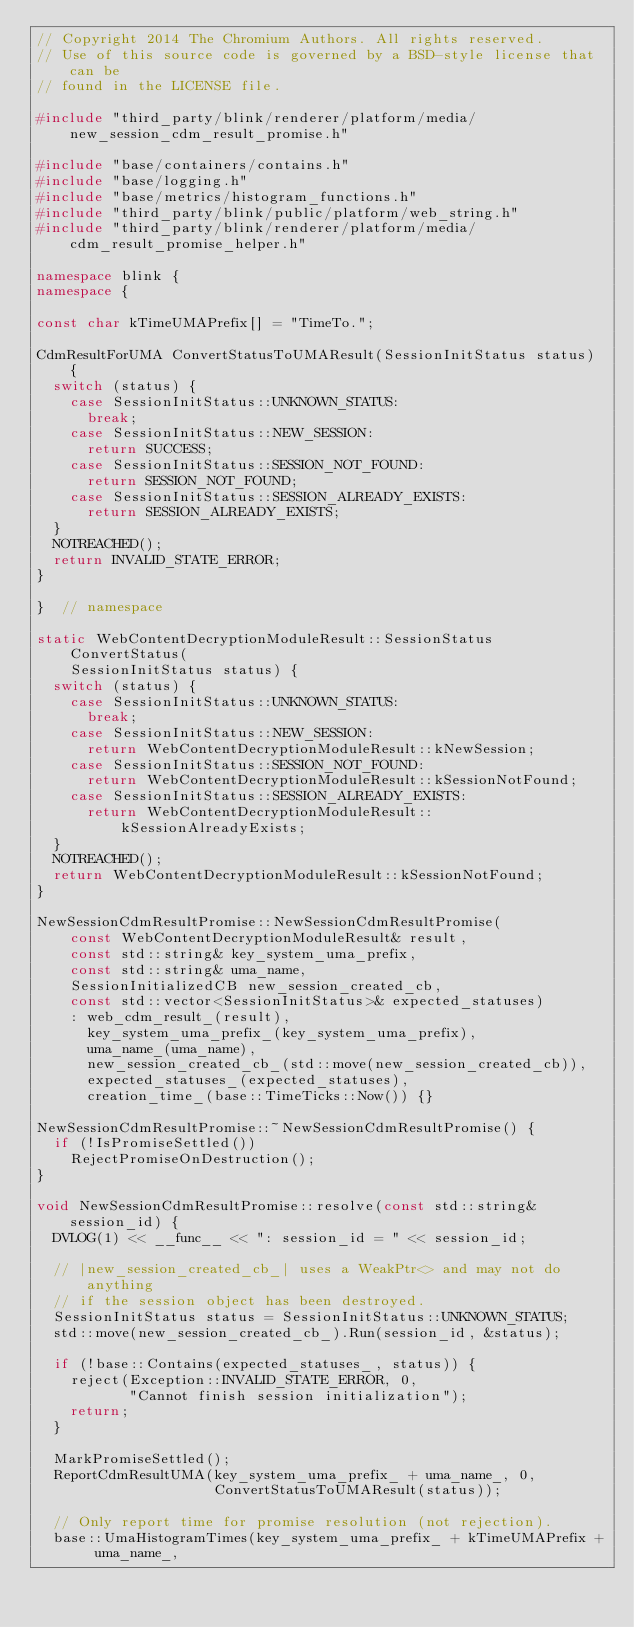Convert code to text. <code><loc_0><loc_0><loc_500><loc_500><_C++_>// Copyright 2014 The Chromium Authors. All rights reserved.
// Use of this source code is governed by a BSD-style license that can be
// found in the LICENSE file.

#include "third_party/blink/renderer/platform/media/new_session_cdm_result_promise.h"

#include "base/containers/contains.h"
#include "base/logging.h"
#include "base/metrics/histogram_functions.h"
#include "third_party/blink/public/platform/web_string.h"
#include "third_party/blink/renderer/platform/media/cdm_result_promise_helper.h"

namespace blink {
namespace {

const char kTimeUMAPrefix[] = "TimeTo.";

CdmResultForUMA ConvertStatusToUMAResult(SessionInitStatus status) {
  switch (status) {
    case SessionInitStatus::UNKNOWN_STATUS:
      break;
    case SessionInitStatus::NEW_SESSION:
      return SUCCESS;
    case SessionInitStatus::SESSION_NOT_FOUND:
      return SESSION_NOT_FOUND;
    case SessionInitStatus::SESSION_ALREADY_EXISTS:
      return SESSION_ALREADY_EXISTS;
  }
  NOTREACHED();
  return INVALID_STATE_ERROR;
}

}  // namespace

static WebContentDecryptionModuleResult::SessionStatus ConvertStatus(
    SessionInitStatus status) {
  switch (status) {
    case SessionInitStatus::UNKNOWN_STATUS:
      break;
    case SessionInitStatus::NEW_SESSION:
      return WebContentDecryptionModuleResult::kNewSession;
    case SessionInitStatus::SESSION_NOT_FOUND:
      return WebContentDecryptionModuleResult::kSessionNotFound;
    case SessionInitStatus::SESSION_ALREADY_EXISTS:
      return WebContentDecryptionModuleResult::kSessionAlreadyExists;
  }
  NOTREACHED();
  return WebContentDecryptionModuleResult::kSessionNotFound;
}

NewSessionCdmResultPromise::NewSessionCdmResultPromise(
    const WebContentDecryptionModuleResult& result,
    const std::string& key_system_uma_prefix,
    const std::string& uma_name,
    SessionInitializedCB new_session_created_cb,
    const std::vector<SessionInitStatus>& expected_statuses)
    : web_cdm_result_(result),
      key_system_uma_prefix_(key_system_uma_prefix),
      uma_name_(uma_name),
      new_session_created_cb_(std::move(new_session_created_cb)),
      expected_statuses_(expected_statuses),
      creation_time_(base::TimeTicks::Now()) {}

NewSessionCdmResultPromise::~NewSessionCdmResultPromise() {
  if (!IsPromiseSettled())
    RejectPromiseOnDestruction();
}

void NewSessionCdmResultPromise::resolve(const std::string& session_id) {
  DVLOG(1) << __func__ << ": session_id = " << session_id;

  // |new_session_created_cb_| uses a WeakPtr<> and may not do anything
  // if the session object has been destroyed.
  SessionInitStatus status = SessionInitStatus::UNKNOWN_STATUS;
  std::move(new_session_created_cb_).Run(session_id, &status);

  if (!base::Contains(expected_statuses_, status)) {
    reject(Exception::INVALID_STATE_ERROR, 0,
           "Cannot finish session initialization");
    return;
  }

  MarkPromiseSettled();
  ReportCdmResultUMA(key_system_uma_prefix_ + uma_name_, 0,
                     ConvertStatusToUMAResult(status));

  // Only report time for promise resolution (not rejection).
  base::UmaHistogramTimes(key_system_uma_prefix_ + kTimeUMAPrefix + uma_name_,</code> 